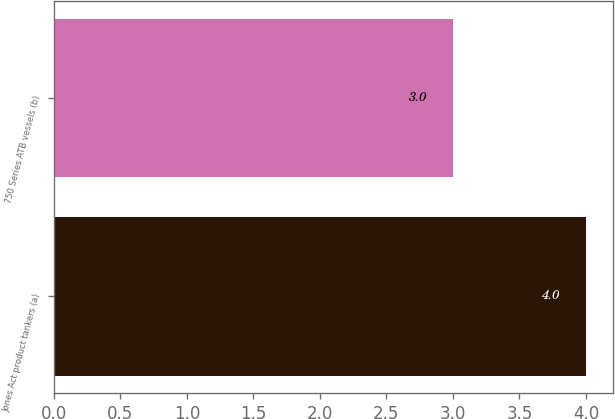Convert chart to OTSL. <chart><loc_0><loc_0><loc_500><loc_500><bar_chart><fcel>Jones Act product tankers (a)<fcel>750 Series ATB vessels (b)<nl><fcel>4<fcel>3<nl></chart> 